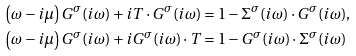<formula> <loc_0><loc_0><loc_500><loc_500>& \left ( \omega - i \mu \right ) G ^ { \sigma } ( i \omega ) + i T \cdot G ^ { \sigma } ( i \omega ) = 1 - \Sigma ^ { \sigma } ( i \omega ) \cdot G ^ { \sigma } ( i \omega ) , \\ & \left ( \omega - i \mu \right ) G ^ { \sigma } ( i \omega ) + i G ^ { \sigma } ( i \omega ) \cdot T = 1 - G ^ { \sigma } ( i \omega ) \cdot \Sigma ^ { \sigma } ( i \omega )</formula> 